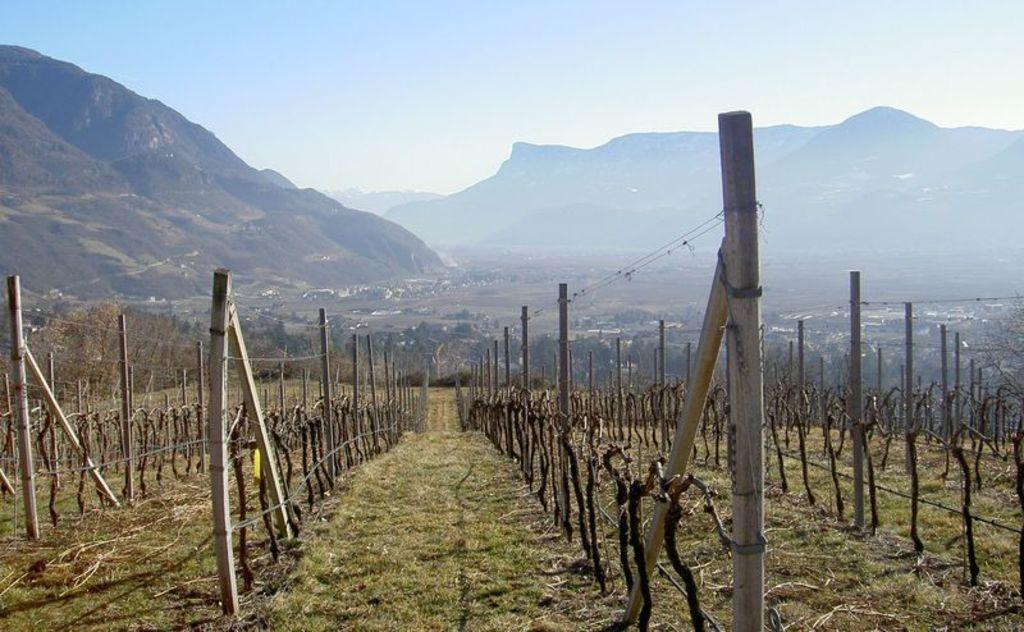What type of vegetation is present in the image? There is grass in the image. What type of structure can be seen in the image? There is a fence in the image. What other natural elements are visible in the image? There are trees and mountains visible in the image. What part of the natural environment is visible in the image? The sky is visible in the image. What type of belief is represented by the cabbage in the image? There is no cabbage present in the image, and therefore no belief can be associated with it. 